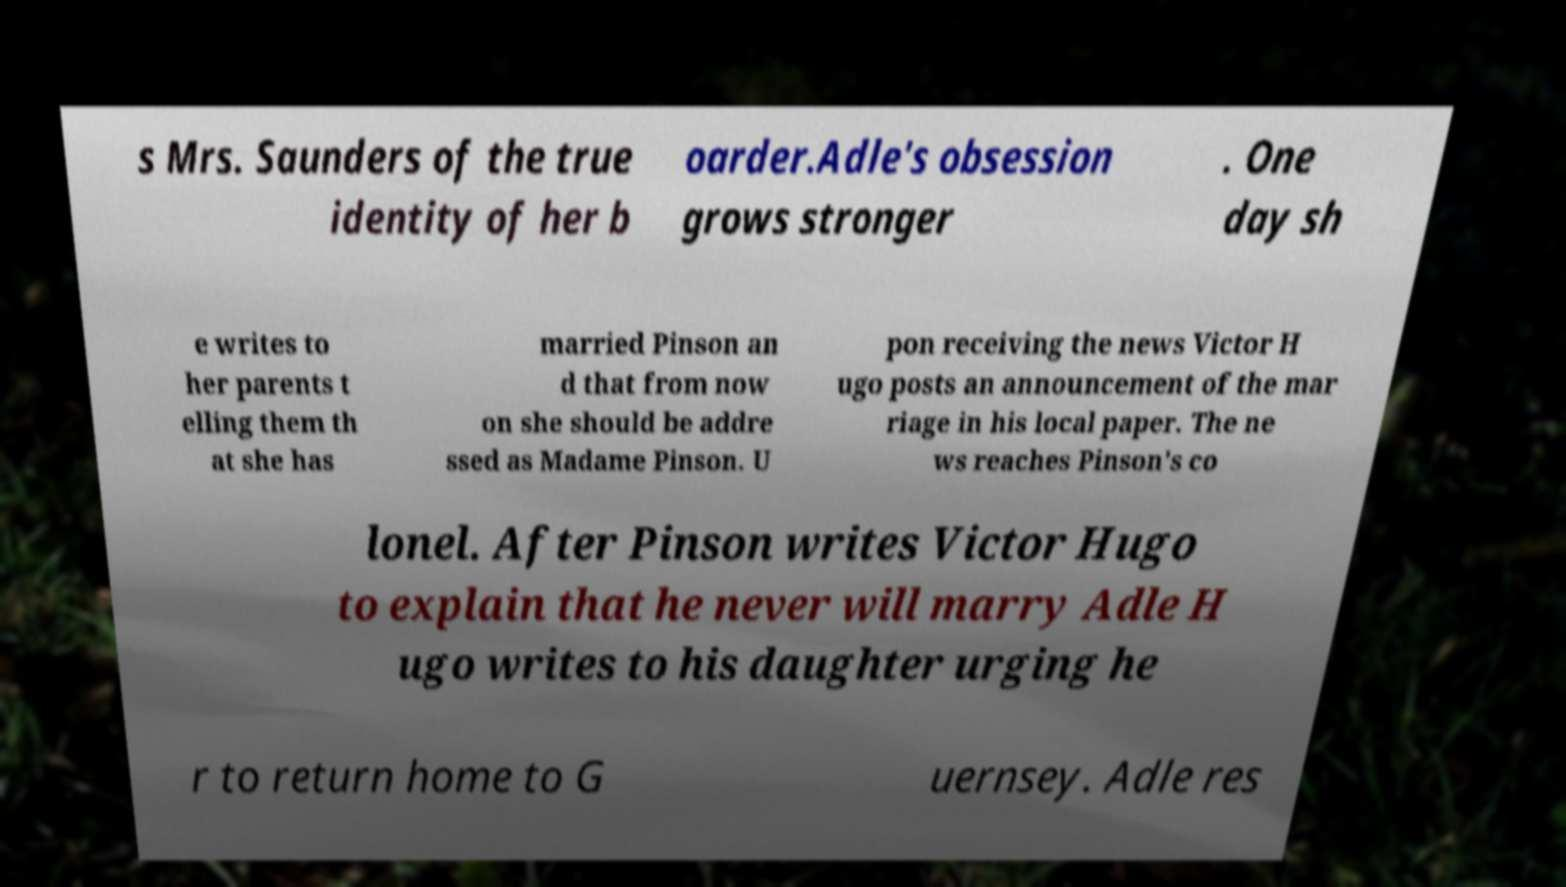Please read and relay the text visible in this image. What does it say? s Mrs. Saunders of the true identity of her b oarder.Adle's obsession grows stronger . One day sh e writes to her parents t elling them th at she has married Pinson an d that from now on she should be addre ssed as Madame Pinson. U pon receiving the news Victor H ugo posts an announcement of the mar riage in his local paper. The ne ws reaches Pinson's co lonel. After Pinson writes Victor Hugo to explain that he never will marry Adle H ugo writes to his daughter urging he r to return home to G uernsey. Adle res 